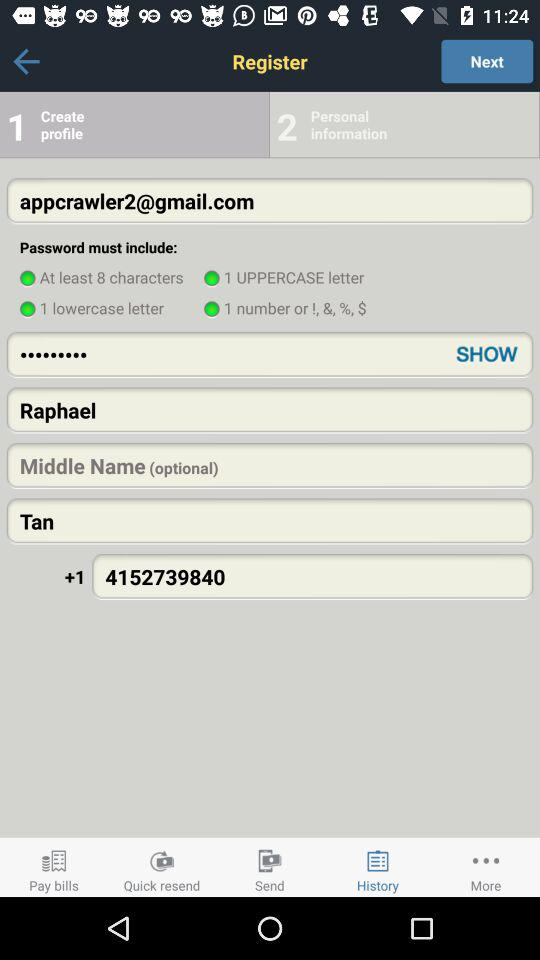Which tab is currently selected? The selected tab is "History". 